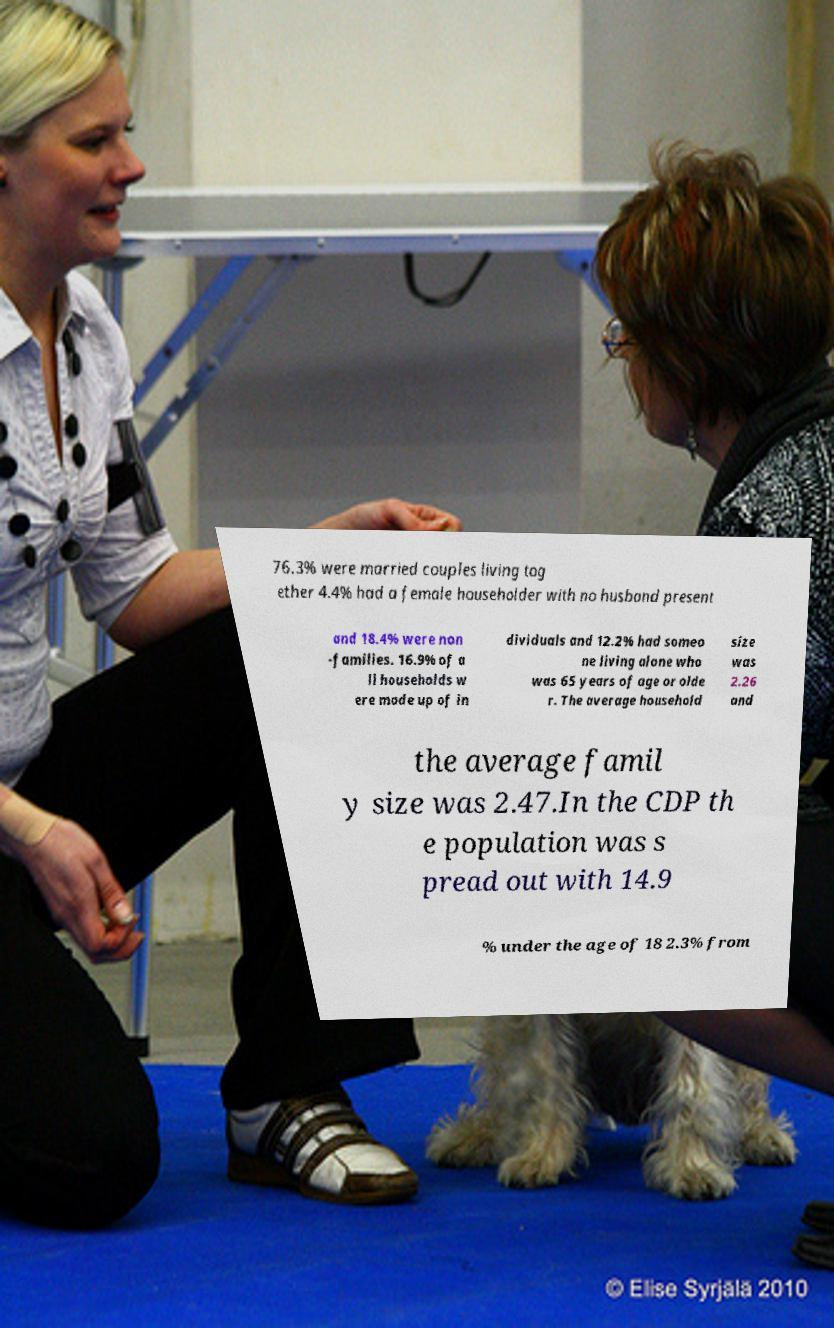Can you accurately transcribe the text from the provided image for me? 76.3% were married couples living tog ether 4.4% had a female householder with no husband present and 18.4% were non -families. 16.9% of a ll households w ere made up of in dividuals and 12.2% had someo ne living alone who was 65 years of age or olde r. The average household size was 2.26 and the average famil y size was 2.47.In the CDP th e population was s pread out with 14.9 % under the age of 18 2.3% from 